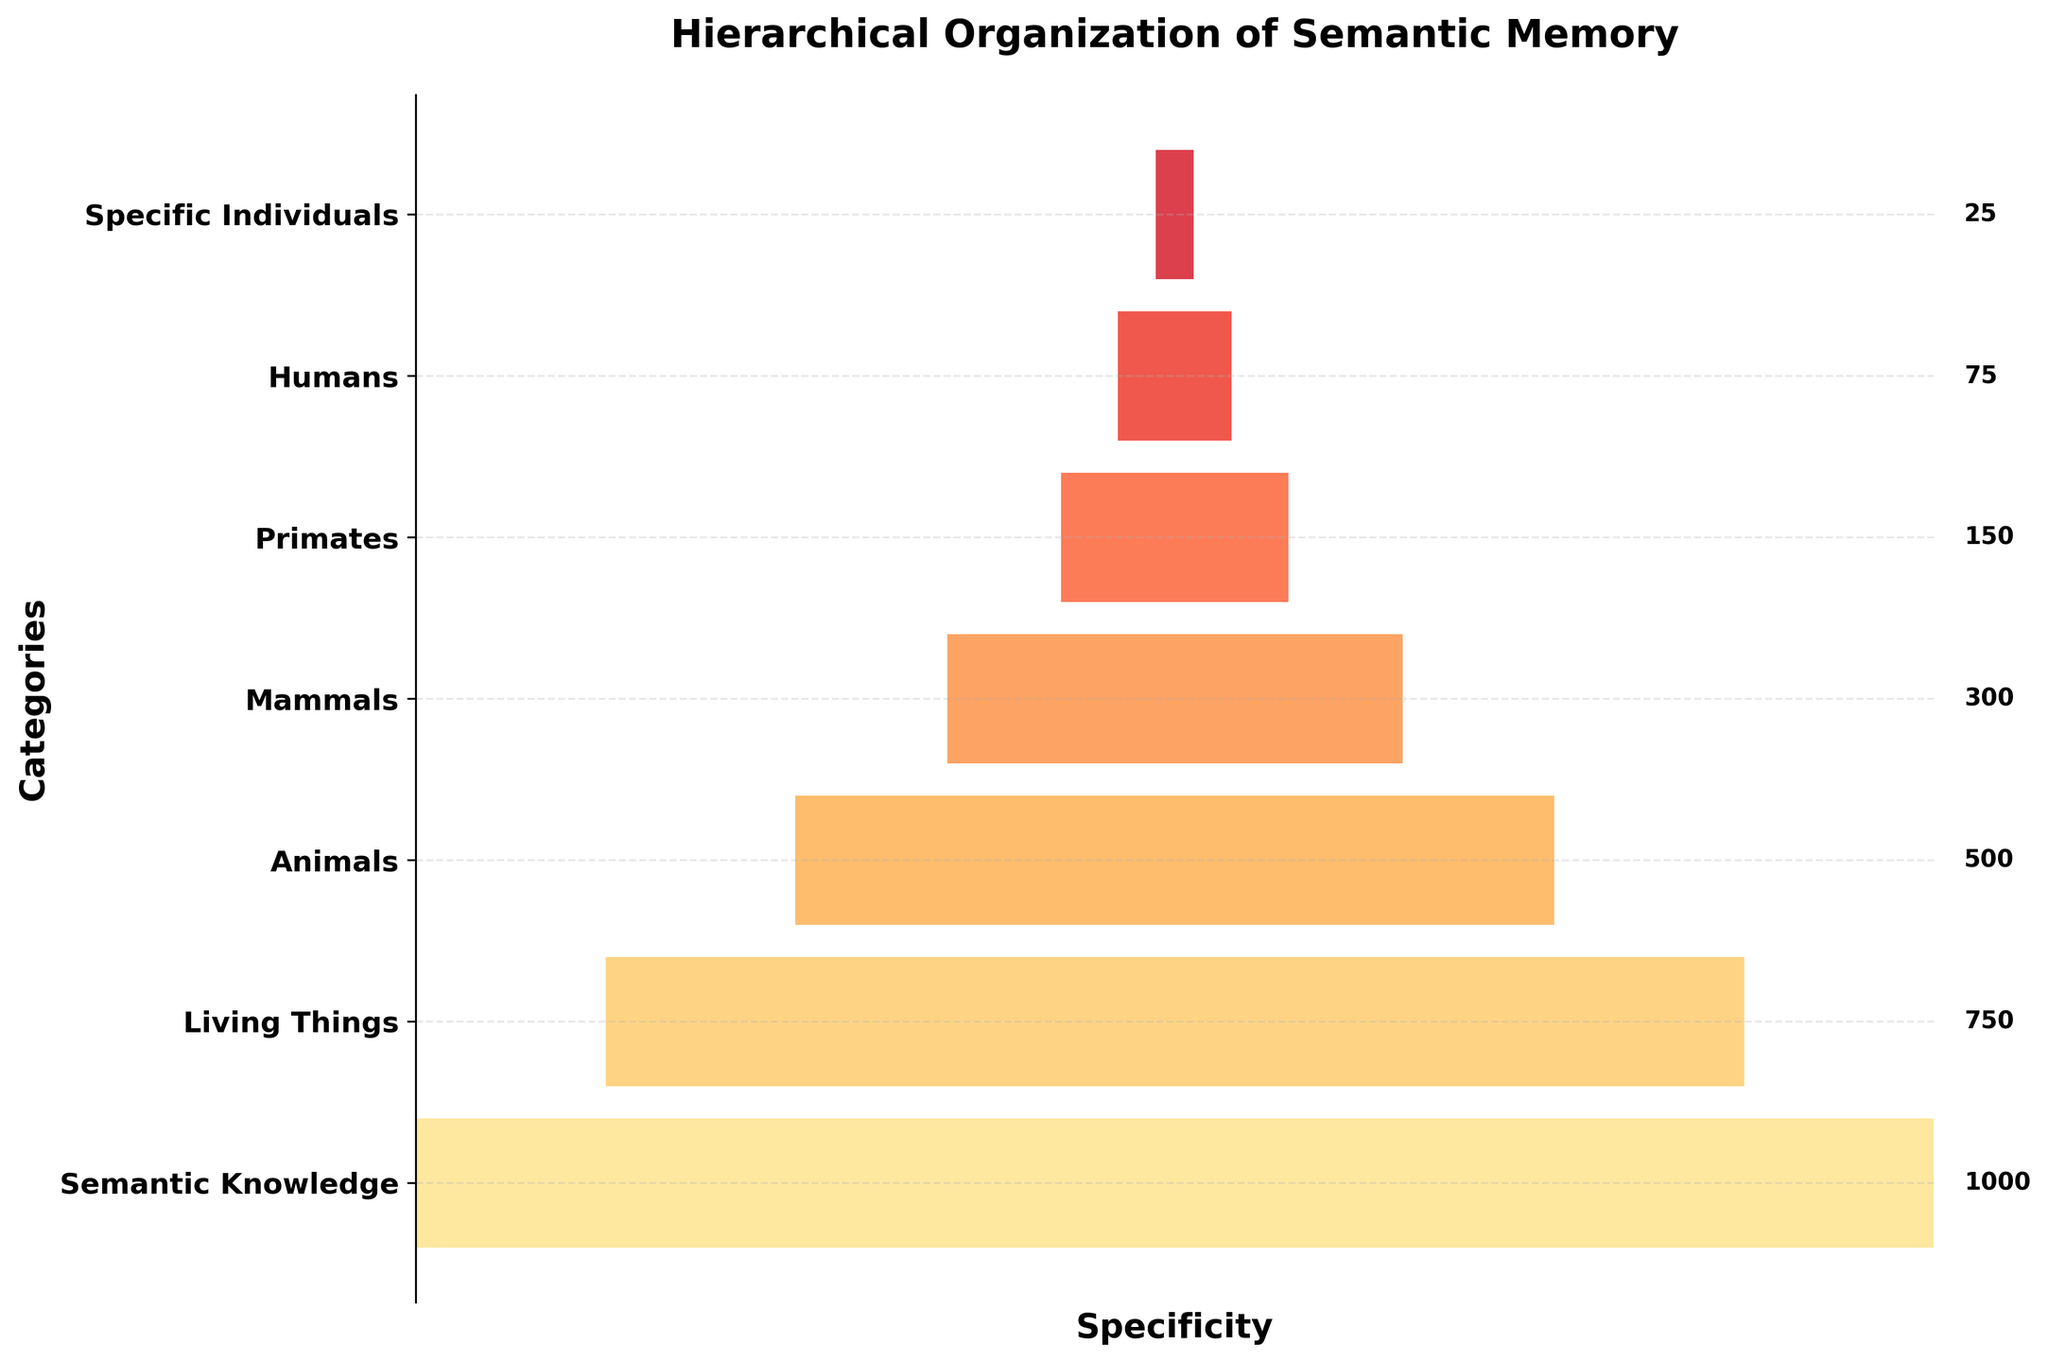What's the title of the plot? The title is written at the top of the plot, in a large, bold font.
Answer: Hierarchical Organization of Semantic Memory What is the total number of instances in the "Living Things" category? The number of instances is displayed next to the "Living Things" bar.
Answer: 750 Which category has the smallest number of instances? Compare the numbers next to each category. The smallest number beside a category is the smallest value.
Answer: Specific Individuals How many more instances are there in the "Mammals" category than in the "Primates" category? Subtract the number of instances in "Primates" from that in "Mammals" (300 - 150).
Answer: 150 What is the combined number of instances for the "Humans" and "Specific Individuals" categories? Add the numbers from the "Humans" and "Specific Individuals" bars (75 + 25).
Answer: 100 Which category has the second highest number of instances? Rank the categories based on the number of instances. The second highest after "Semantic Knowledge" is "Living Things".
Answer: Living Things Arrange the categories from most specific to least specific. Follow the structure from the bottom to the top of the funnel, which goes from specific to general.
Answer: Specific Individuals, Humans, Primates, Mammals, Animals, Living Things, Semantic Knowledge What is the purpose of the gradient shading in the funnel chart? The gradient likely indicates hierarchical organization, with different levels of specificity. Darker shades may represent more specific categories, while lighter shades represent broader categories.
Answer: To indicate different levels of specificity How does "Animals" compare to "Living Things" in terms of the number of instances? Compare the numbers next to the "Animals" and "Living Things" categories. "Animals" has fewer instances than "Living Things".
Answer: "Animals" has fewer instances What does the x-axis represent in this funnel chart? Since the x-axis has no ticks or labels, it likely represents specificity. The widest part of the bars is to the left, indicating more instances and less specificity; narrower parts indicate fewer instances and more specificity.
Answer: Specificity 